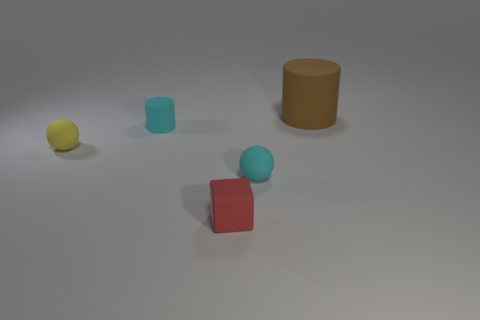Do the cylinder in front of the brown matte cylinder and the small ball that is right of the tiny matte block have the same material?
Your answer should be very brief. Yes. What size is the cylinder right of the tiny object in front of the rubber sphere right of the red matte block?
Your answer should be very brief. Large. What number of other cylinders have the same material as the brown cylinder?
Keep it short and to the point. 1. Are there fewer brown rubber things than big yellow shiny cylinders?
Provide a short and direct response. No. What number of things are either things left of the brown matte cylinder or cyan matte things?
Provide a succinct answer. 4. What is the size of the yellow thing that is the same material as the tiny block?
Give a very brief answer. Small. How many matte spheres are the same color as the small cylinder?
Your response must be concise. 1. How many large things are blue cubes or red blocks?
Offer a terse response. 0. There is a matte sphere that is the same color as the small cylinder; what is its size?
Keep it short and to the point. Small. Is there a cylinder that has the same material as the small cube?
Offer a terse response. Yes. 